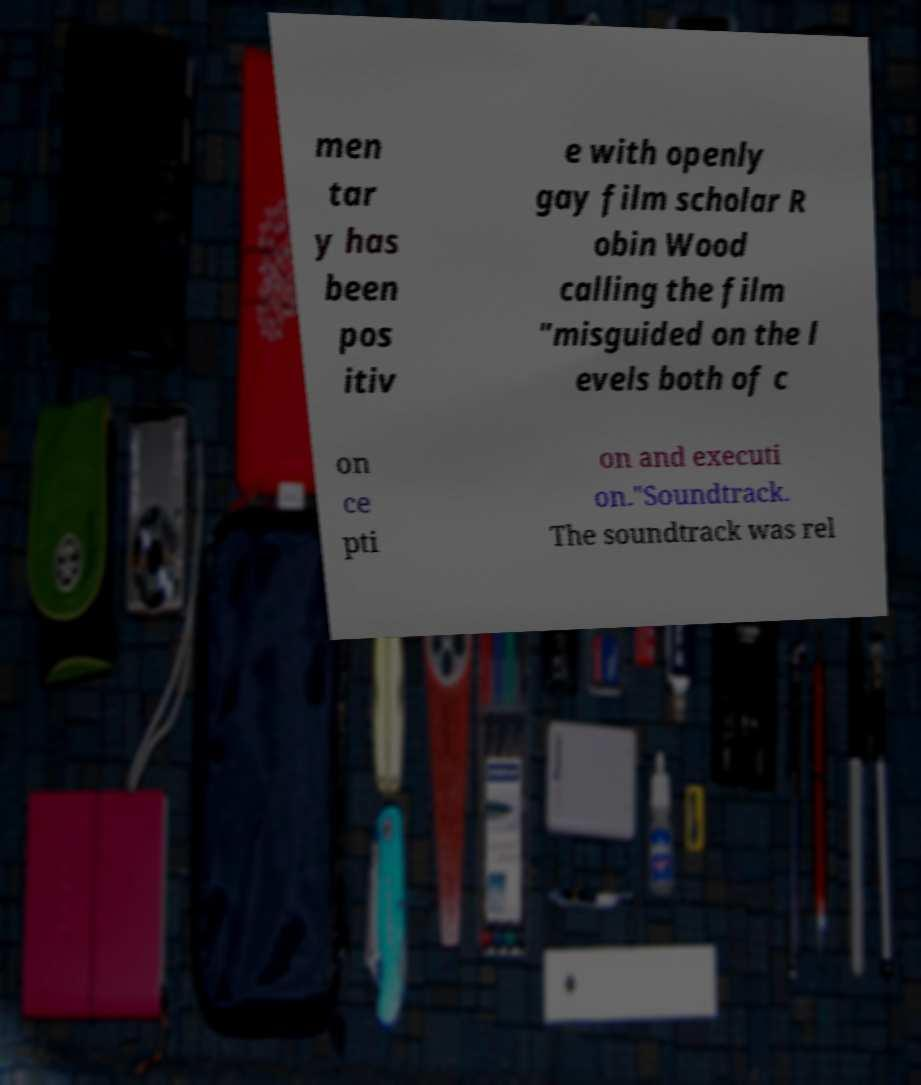Please read and relay the text visible in this image. What does it say? men tar y has been pos itiv e with openly gay film scholar R obin Wood calling the film "misguided on the l evels both of c on ce pti on and executi on."Soundtrack. The soundtrack was rel 